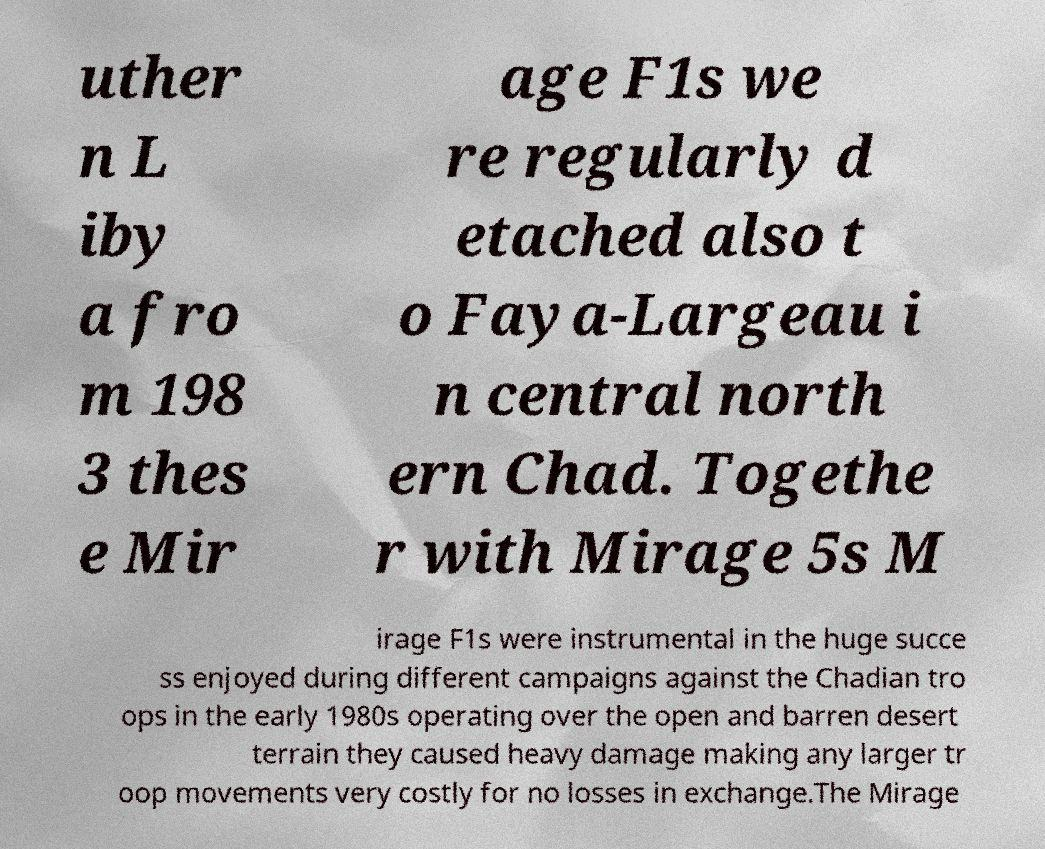Please read and relay the text visible in this image. What does it say? uther n L iby a fro m 198 3 thes e Mir age F1s we re regularly d etached also t o Faya-Largeau i n central north ern Chad. Togethe r with Mirage 5s M irage F1s were instrumental in the huge succe ss enjoyed during different campaigns against the Chadian tro ops in the early 1980s operating over the open and barren desert terrain they caused heavy damage making any larger tr oop movements very costly for no losses in exchange.The Mirage 